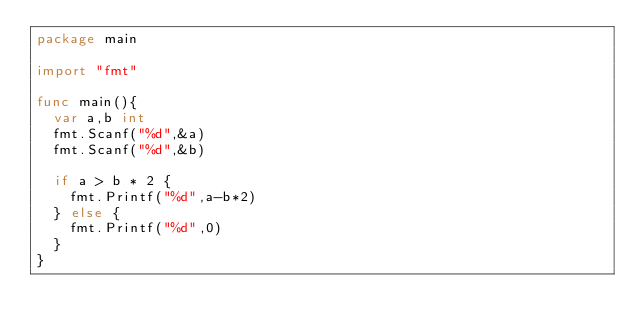Convert code to text. <code><loc_0><loc_0><loc_500><loc_500><_Go_>package main

import "fmt"

func main(){
  var a,b int
  fmt.Scanf("%d",&a)
  fmt.Scanf("%d",&b)
  
  if a > b * 2 {
    fmt.Printf("%d",a-b*2)
  } else {
    fmt.Printf("%d",0)
  }
}</code> 